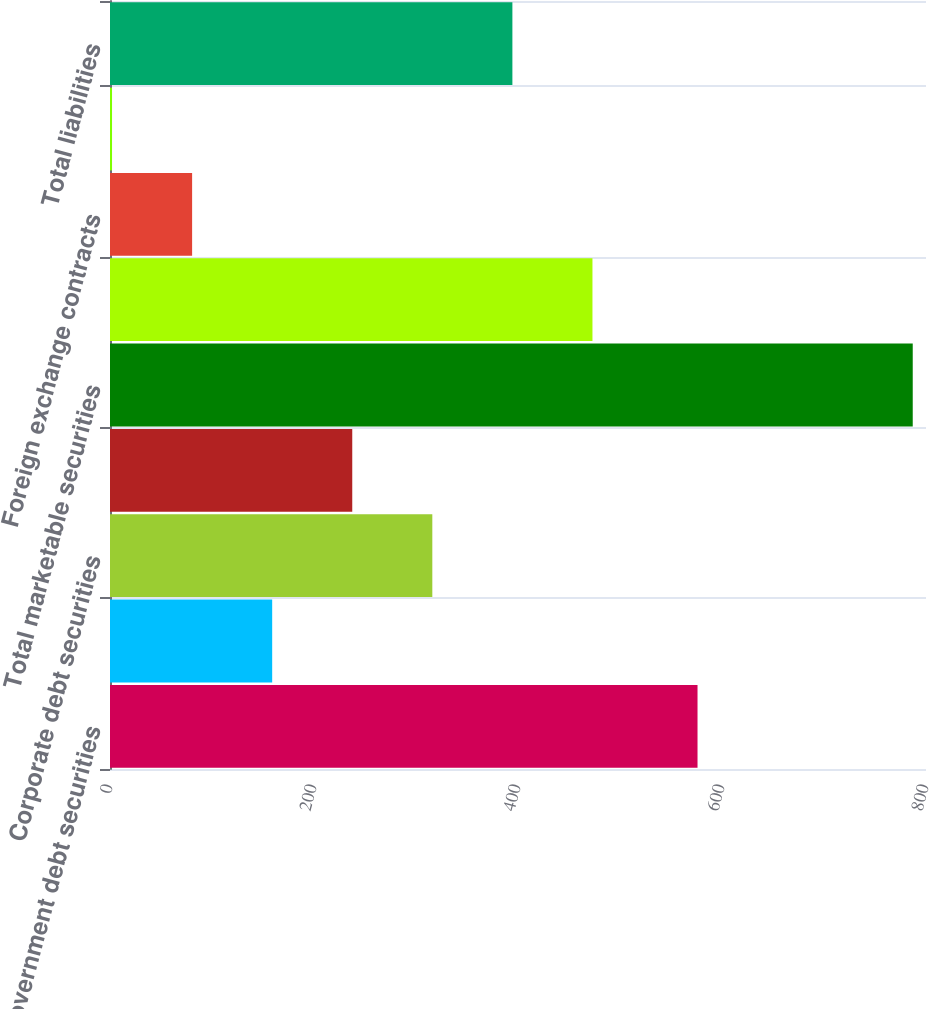Convert chart. <chart><loc_0><loc_0><loc_500><loc_500><bar_chart><fcel>US government debt securities<fcel>Municipal debt securities<fcel>Corporate debt securities<fcel>Residential mortgage-backed<fcel>Total marketable securities<fcel>Interest rate contracts<fcel>Foreign exchange contracts<fcel>Cross-currency interest rate<fcel>Total liabilities<nl><fcel>576<fcel>159<fcel>316<fcel>237.5<fcel>787<fcel>473<fcel>80.5<fcel>2<fcel>394.5<nl></chart> 